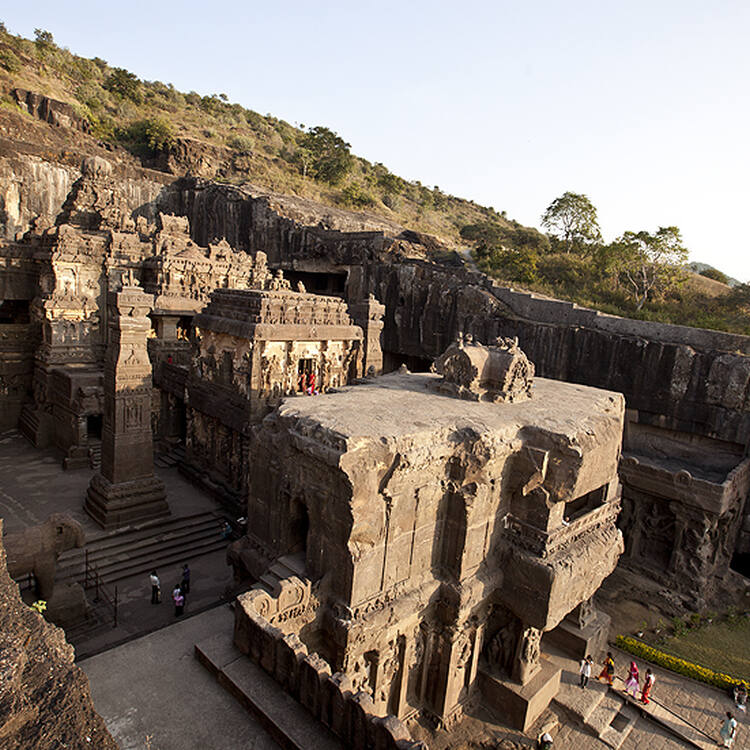Who built the Ellora Caves and how long did it take? The Ellora Caves were built by various dynasties over a span of about 400 years. The earliest Buddhist caves were constructed under the patronage of the Vakataka Dynasty during the 5th and 6th centuries. Subsequently, the Hindu caves were developed under the Rashtrakuta rule in the 7th and 8th centuries, and the Jain caves under the Yadava Dynasty in the 9th and 10th centuries. This collaborative effort from different time periods and rulers underscores the historical and cultural significance of the site. 